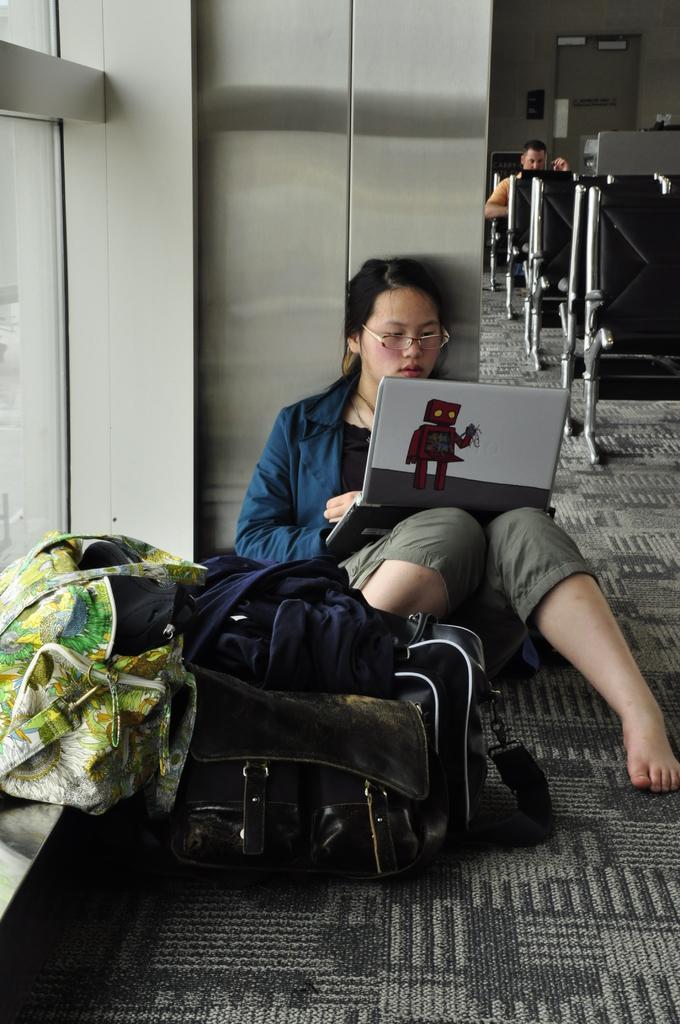How would you summarize this image in a sentence or two? In this image we can see a woman sitting on a floor and she is working on a laptop. Here we can see a few bags which are on the left side. In the background we can see a person sitting on a chair and he is on the top right side. 